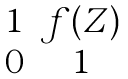<formula> <loc_0><loc_0><loc_500><loc_500>\begin{matrix} 1 & f ( Z ) \\ 0 & 1 \\ \end{matrix}</formula> 